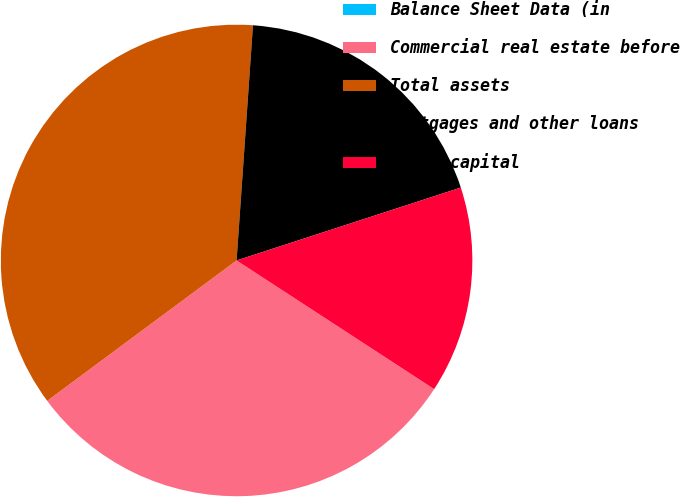<chart> <loc_0><loc_0><loc_500><loc_500><pie_chart><fcel>Balance Sheet Data (in<fcel>Commercial real estate before<fcel>Total assets<fcel>Mortgages and other loans<fcel>Total capital<nl><fcel>0.0%<fcel>30.66%<fcel>36.26%<fcel>18.89%<fcel>14.19%<nl></chart> 